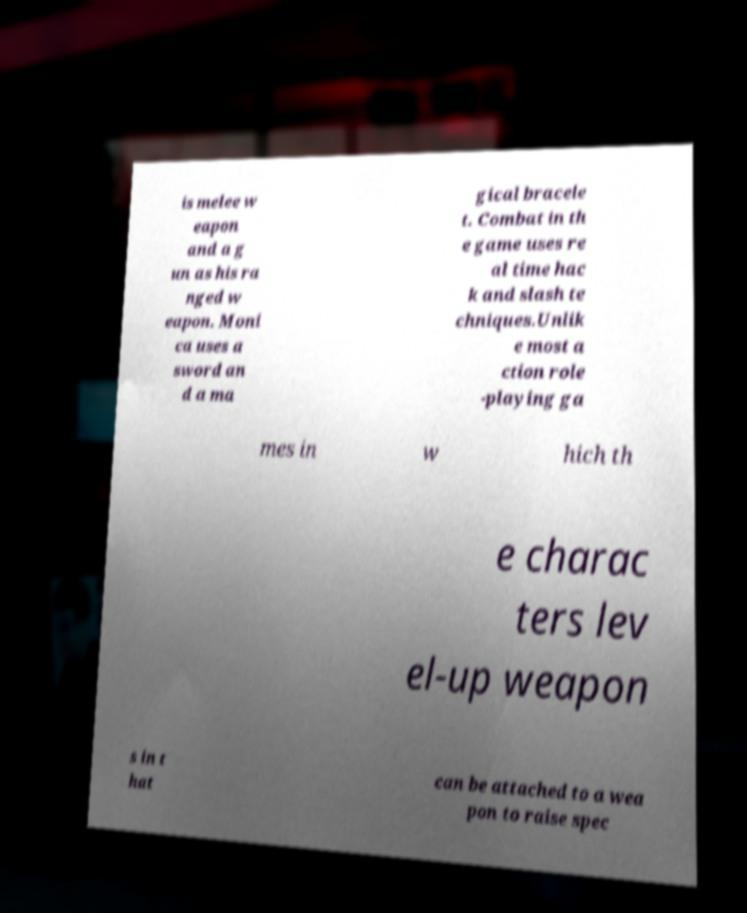There's text embedded in this image that I need extracted. Can you transcribe it verbatim? is melee w eapon and a g un as his ra nged w eapon. Moni ca uses a sword an d a ma gical bracele t. Combat in th e game uses re al time hac k and slash te chniques.Unlik e most a ction role -playing ga mes in w hich th e charac ters lev el-up weapon s in t hat can be attached to a wea pon to raise spec 